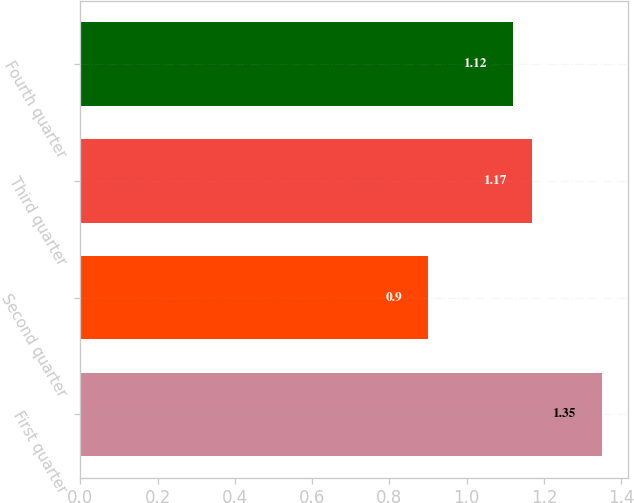Convert chart to OTSL. <chart><loc_0><loc_0><loc_500><loc_500><bar_chart><fcel>First quarter<fcel>Second quarter<fcel>Third quarter<fcel>Fourth quarter<nl><fcel>1.35<fcel>0.9<fcel>1.17<fcel>1.12<nl></chart> 